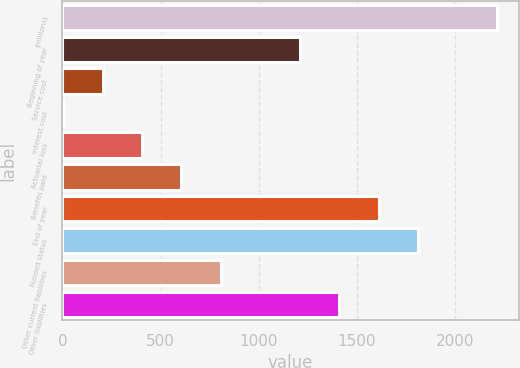Convert chart to OTSL. <chart><loc_0><loc_0><loc_500><loc_500><bar_chart><fcel>(millions)<fcel>Beginning of year<fcel>Service cost<fcel>Interest cost<fcel>Actuarial loss<fcel>Benefits paid<fcel>End of year<fcel>Funded status<fcel>Other current liabilities<fcel>Other liabilities<nl><fcel>2212.8<fcel>1208.8<fcel>204.8<fcel>4<fcel>405.6<fcel>606.4<fcel>1610.4<fcel>1811.2<fcel>807.2<fcel>1409.6<nl></chart> 